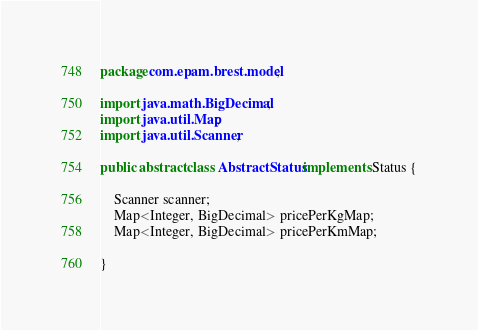<code> <loc_0><loc_0><loc_500><loc_500><_Java_>package com.epam.brest.model;

import java.math.BigDecimal;
import java.util.Map;
import java.util.Scanner;

public abstract class AbstractStatus implements Status {

    Scanner scanner;
    Map<Integer, BigDecimal> pricePerKgMap;
    Map<Integer, BigDecimal> pricePerKmMap;

}
</code> 